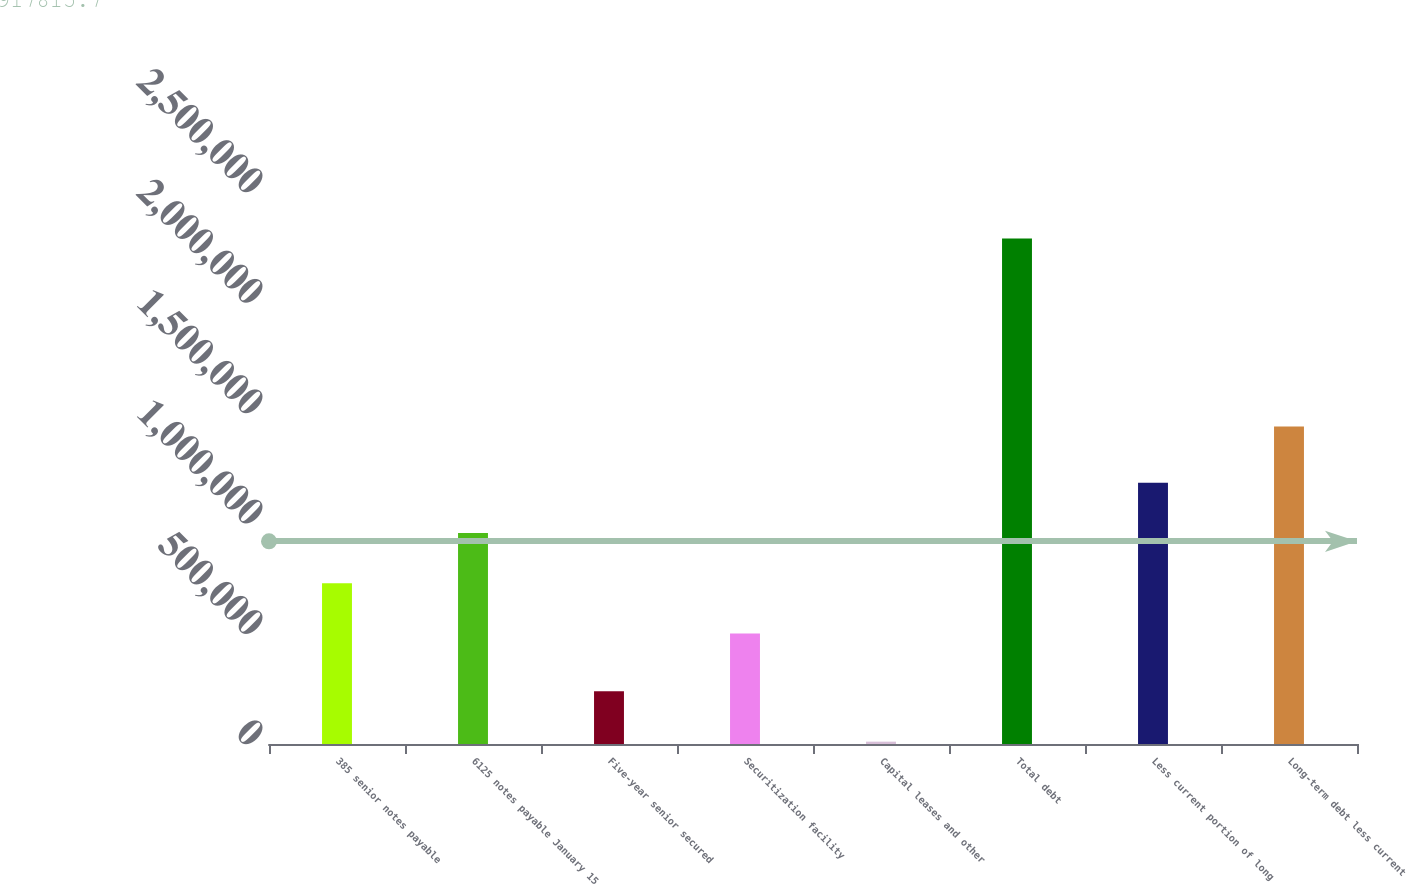Convert chart to OTSL. <chart><loc_0><loc_0><loc_500><loc_500><bar_chart><fcel>385 senior notes payable<fcel>6125 notes payable January 15<fcel>Five-year senior secured<fcel>Securitization facility<fcel>Capital leases and other<fcel>Total debt<fcel>Less current portion of long<fcel>Long-term debt less current<nl><fcel>727828<fcel>955656<fcel>238448<fcel>500000<fcel>10620<fcel>2.2889e+06<fcel>1.18348e+06<fcel>1.43759e+06<nl></chart> 